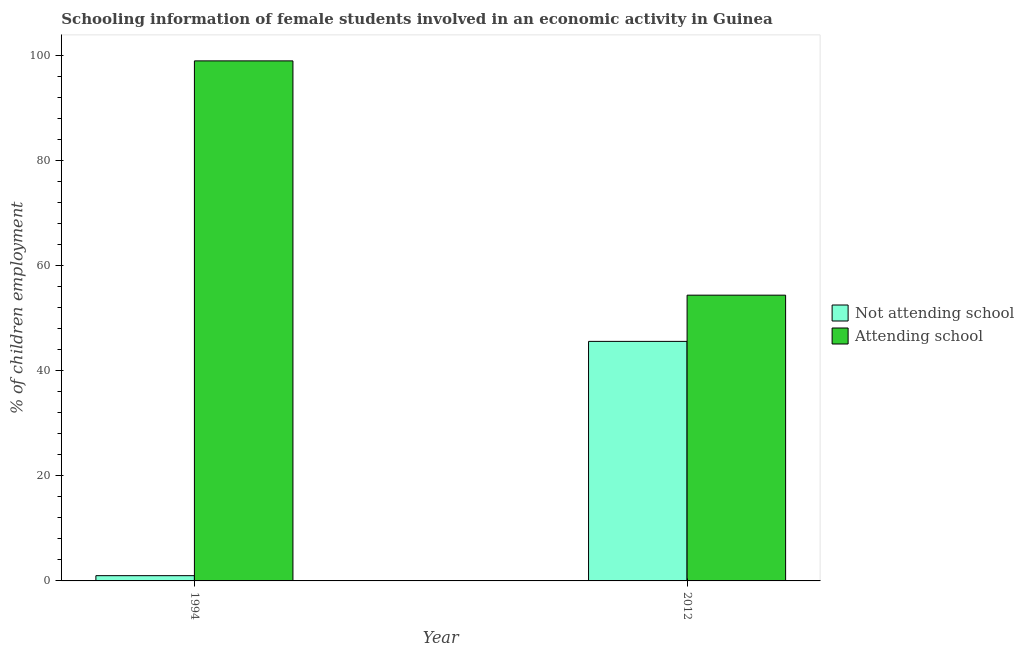Are the number of bars on each tick of the X-axis equal?
Your answer should be very brief. Yes. How many bars are there on the 2nd tick from the right?
Make the answer very short. 2. What is the label of the 2nd group of bars from the left?
Provide a succinct answer. 2012. Across all years, what is the maximum percentage of employed females who are not attending school?
Keep it short and to the point. 45.6. Across all years, what is the minimum percentage of employed females who are attending school?
Provide a short and direct response. 54.4. What is the total percentage of employed females who are not attending school in the graph?
Ensure brevity in your answer.  46.6. What is the difference between the percentage of employed females who are not attending school in 1994 and that in 2012?
Provide a short and direct response. -44.6. What is the difference between the percentage of employed females who are not attending school in 1994 and the percentage of employed females who are attending school in 2012?
Provide a short and direct response. -44.6. What is the average percentage of employed females who are not attending school per year?
Provide a succinct answer. 23.3. In how many years, is the percentage of employed females who are attending school greater than 48 %?
Offer a very short reply. 2. What is the ratio of the percentage of employed females who are attending school in 1994 to that in 2012?
Provide a short and direct response. 1.82. Is the percentage of employed females who are attending school in 1994 less than that in 2012?
Provide a short and direct response. No. In how many years, is the percentage of employed females who are attending school greater than the average percentage of employed females who are attending school taken over all years?
Your answer should be very brief. 1. What does the 2nd bar from the left in 2012 represents?
Make the answer very short. Attending school. What does the 2nd bar from the right in 2012 represents?
Make the answer very short. Not attending school. Are the values on the major ticks of Y-axis written in scientific E-notation?
Make the answer very short. No. Does the graph contain any zero values?
Provide a short and direct response. No. How are the legend labels stacked?
Provide a short and direct response. Vertical. What is the title of the graph?
Your response must be concise. Schooling information of female students involved in an economic activity in Guinea. What is the label or title of the Y-axis?
Give a very brief answer. % of children employment. What is the % of children employment of Not attending school in 1994?
Give a very brief answer. 1. What is the % of children employment in Not attending school in 2012?
Your answer should be very brief. 45.6. What is the % of children employment in Attending school in 2012?
Provide a short and direct response. 54.4. Across all years, what is the maximum % of children employment in Not attending school?
Keep it short and to the point. 45.6. Across all years, what is the minimum % of children employment of Attending school?
Provide a succinct answer. 54.4. What is the total % of children employment in Not attending school in the graph?
Give a very brief answer. 46.6. What is the total % of children employment of Attending school in the graph?
Keep it short and to the point. 153.4. What is the difference between the % of children employment of Not attending school in 1994 and that in 2012?
Your answer should be very brief. -44.6. What is the difference between the % of children employment in Attending school in 1994 and that in 2012?
Ensure brevity in your answer.  44.6. What is the difference between the % of children employment in Not attending school in 1994 and the % of children employment in Attending school in 2012?
Keep it short and to the point. -53.4. What is the average % of children employment in Not attending school per year?
Provide a short and direct response. 23.3. What is the average % of children employment of Attending school per year?
Offer a very short reply. 76.7. In the year 1994, what is the difference between the % of children employment of Not attending school and % of children employment of Attending school?
Offer a very short reply. -98. What is the ratio of the % of children employment of Not attending school in 1994 to that in 2012?
Ensure brevity in your answer.  0.02. What is the ratio of the % of children employment of Attending school in 1994 to that in 2012?
Keep it short and to the point. 1.82. What is the difference between the highest and the second highest % of children employment in Not attending school?
Provide a succinct answer. 44.6. What is the difference between the highest and the second highest % of children employment of Attending school?
Offer a terse response. 44.6. What is the difference between the highest and the lowest % of children employment of Not attending school?
Provide a succinct answer. 44.6. What is the difference between the highest and the lowest % of children employment of Attending school?
Give a very brief answer. 44.6. 